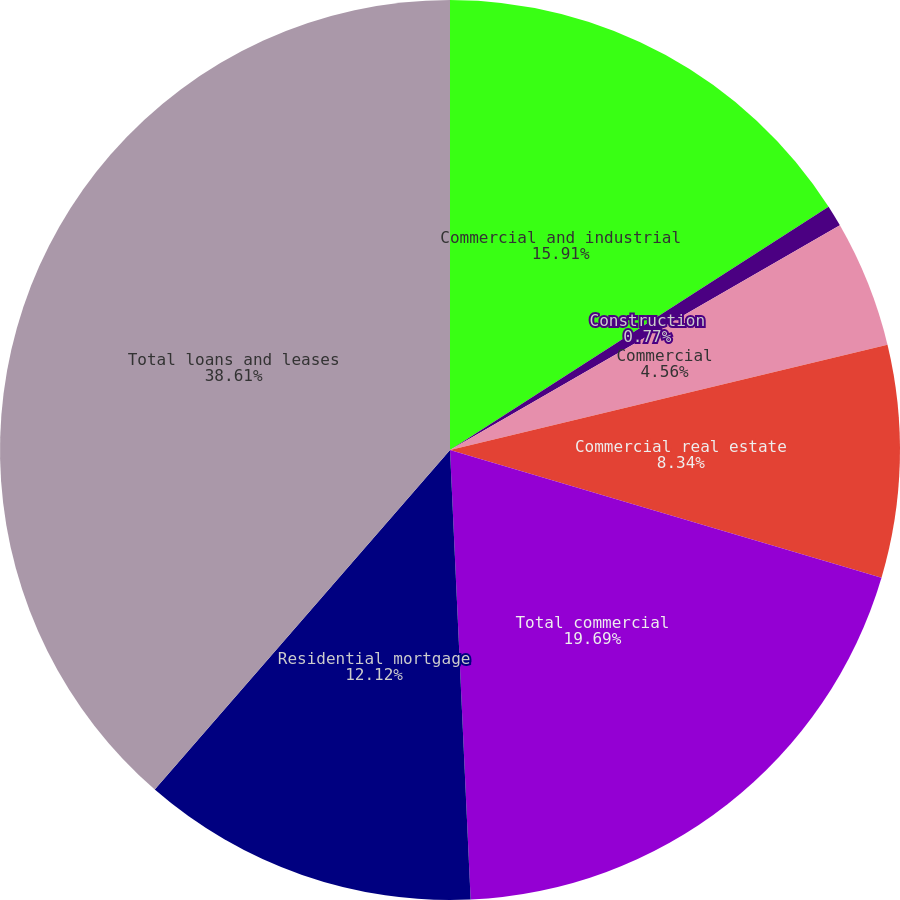Convert chart. <chart><loc_0><loc_0><loc_500><loc_500><pie_chart><fcel>Commercial and industrial<fcel>Construction<fcel>Commercial<fcel>Commercial real estate<fcel>Total commercial<fcel>Residential mortgage<fcel>Total loans and leases<nl><fcel>15.91%<fcel>0.77%<fcel>4.56%<fcel>8.34%<fcel>19.69%<fcel>12.12%<fcel>38.61%<nl></chart> 